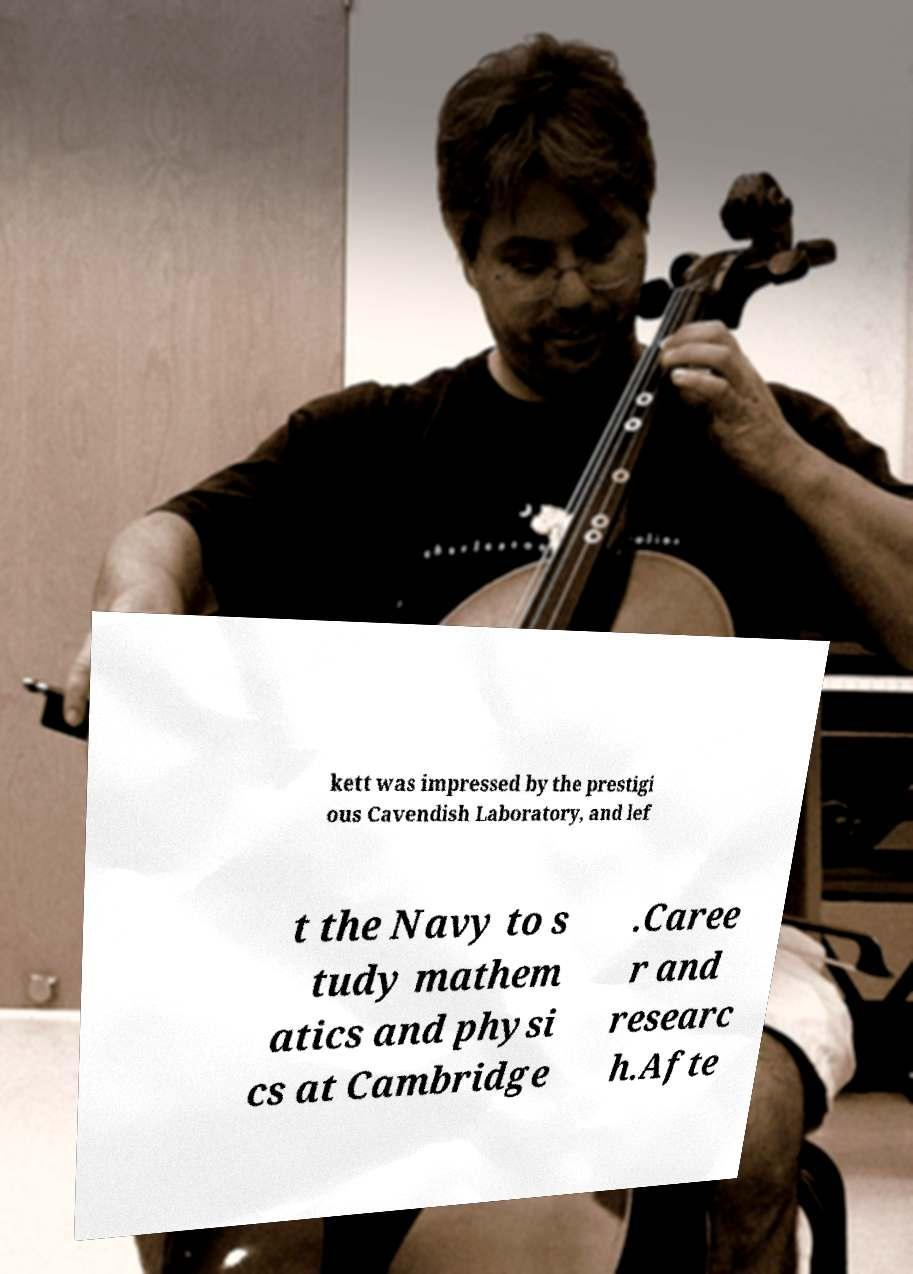Could you assist in decoding the text presented in this image and type it out clearly? kett was impressed by the prestigi ous Cavendish Laboratory, and lef t the Navy to s tudy mathem atics and physi cs at Cambridge .Caree r and researc h.Afte 